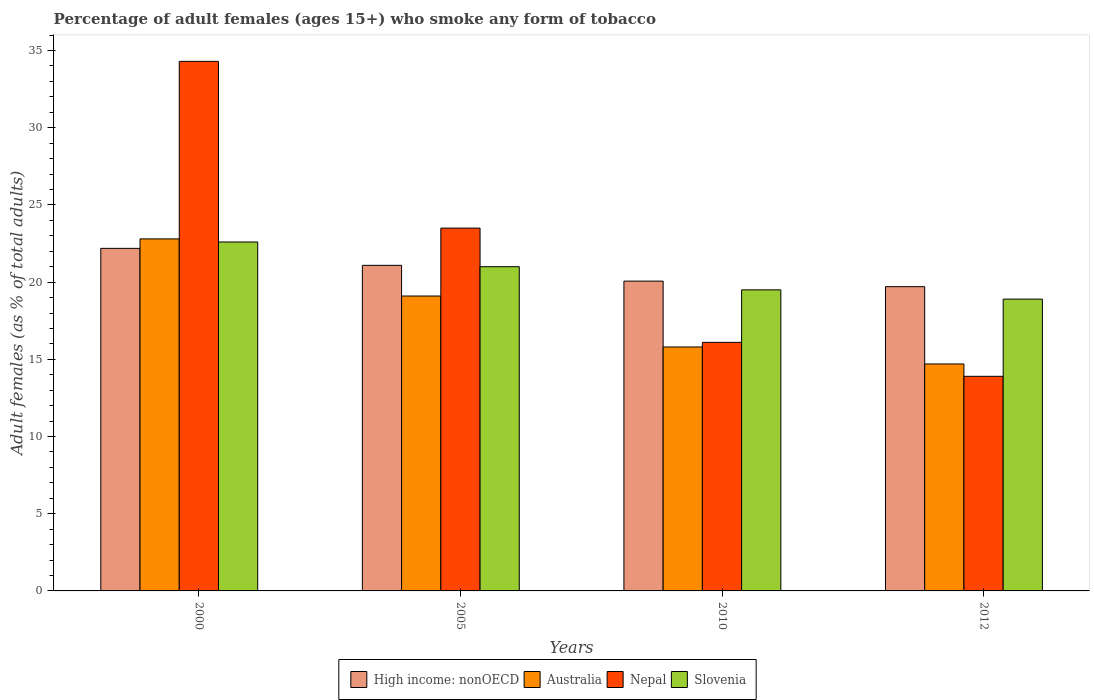How many different coloured bars are there?
Keep it short and to the point. 4. Are the number of bars per tick equal to the number of legend labels?
Offer a very short reply. Yes. Are the number of bars on each tick of the X-axis equal?
Your answer should be compact. Yes. How many bars are there on the 3rd tick from the left?
Your response must be concise. 4. What is the label of the 2nd group of bars from the left?
Ensure brevity in your answer.  2005. What is the percentage of adult females who smoke in High income: nonOECD in 2000?
Your answer should be very brief. 22.19. Across all years, what is the maximum percentage of adult females who smoke in High income: nonOECD?
Provide a succinct answer. 22.19. In which year was the percentage of adult females who smoke in Slovenia maximum?
Your answer should be compact. 2000. In which year was the percentage of adult females who smoke in High income: nonOECD minimum?
Offer a very short reply. 2012. What is the total percentage of adult females who smoke in High income: nonOECD in the graph?
Offer a terse response. 83.05. What is the difference between the percentage of adult females who smoke in Australia in 2000 and the percentage of adult females who smoke in Slovenia in 2012?
Provide a short and direct response. 3.9. In the year 2010, what is the difference between the percentage of adult females who smoke in High income: nonOECD and percentage of adult females who smoke in Nepal?
Offer a very short reply. 3.97. In how many years, is the percentage of adult females who smoke in High income: nonOECD greater than 16 %?
Keep it short and to the point. 4. What is the ratio of the percentage of adult females who smoke in Australia in 2000 to that in 2010?
Give a very brief answer. 1.44. What is the difference between the highest and the second highest percentage of adult females who smoke in Australia?
Offer a very short reply. 3.7. What is the difference between the highest and the lowest percentage of adult females who smoke in Australia?
Provide a short and direct response. 8.1. Is it the case that in every year, the sum of the percentage of adult females who smoke in High income: nonOECD and percentage of adult females who smoke in Australia is greater than the sum of percentage of adult females who smoke in Slovenia and percentage of adult females who smoke in Nepal?
Give a very brief answer. No. What does the 3rd bar from the left in 2010 represents?
Make the answer very short. Nepal. What does the 1st bar from the right in 2005 represents?
Make the answer very short. Slovenia. How many bars are there?
Give a very brief answer. 16. What is the difference between two consecutive major ticks on the Y-axis?
Offer a very short reply. 5. Does the graph contain grids?
Your answer should be very brief. No. How many legend labels are there?
Provide a succinct answer. 4. How are the legend labels stacked?
Ensure brevity in your answer.  Horizontal. What is the title of the graph?
Give a very brief answer. Percentage of adult females (ages 15+) who smoke any form of tobacco. What is the label or title of the X-axis?
Give a very brief answer. Years. What is the label or title of the Y-axis?
Make the answer very short. Adult females (as % of total adults). What is the Adult females (as % of total adults) in High income: nonOECD in 2000?
Your answer should be compact. 22.19. What is the Adult females (as % of total adults) in Australia in 2000?
Offer a very short reply. 22.8. What is the Adult females (as % of total adults) of Nepal in 2000?
Your answer should be compact. 34.3. What is the Adult females (as % of total adults) of Slovenia in 2000?
Your answer should be compact. 22.6. What is the Adult females (as % of total adults) in High income: nonOECD in 2005?
Your response must be concise. 21.09. What is the Adult females (as % of total adults) of Australia in 2005?
Offer a terse response. 19.1. What is the Adult females (as % of total adults) of Slovenia in 2005?
Your answer should be compact. 21. What is the Adult females (as % of total adults) in High income: nonOECD in 2010?
Offer a very short reply. 20.07. What is the Adult females (as % of total adults) of Slovenia in 2010?
Provide a short and direct response. 19.5. What is the Adult females (as % of total adults) of High income: nonOECD in 2012?
Your answer should be very brief. 19.71. What is the Adult females (as % of total adults) of Nepal in 2012?
Your response must be concise. 13.9. What is the Adult females (as % of total adults) in Slovenia in 2012?
Give a very brief answer. 18.9. Across all years, what is the maximum Adult females (as % of total adults) of High income: nonOECD?
Your answer should be very brief. 22.19. Across all years, what is the maximum Adult females (as % of total adults) of Australia?
Your answer should be compact. 22.8. Across all years, what is the maximum Adult females (as % of total adults) in Nepal?
Your answer should be compact. 34.3. Across all years, what is the maximum Adult females (as % of total adults) in Slovenia?
Give a very brief answer. 22.6. Across all years, what is the minimum Adult females (as % of total adults) in High income: nonOECD?
Your response must be concise. 19.71. Across all years, what is the minimum Adult females (as % of total adults) of Australia?
Provide a short and direct response. 14.7. Across all years, what is the minimum Adult females (as % of total adults) of Slovenia?
Keep it short and to the point. 18.9. What is the total Adult females (as % of total adults) in High income: nonOECD in the graph?
Your answer should be compact. 83.05. What is the total Adult females (as % of total adults) in Australia in the graph?
Provide a short and direct response. 72.4. What is the total Adult females (as % of total adults) of Nepal in the graph?
Offer a terse response. 87.8. What is the difference between the Adult females (as % of total adults) of High income: nonOECD in 2000 and that in 2005?
Provide a succinct answer. 1.1. What is the difference between the Adult females (as % of total adults) of Australia in 2000 and that in 2005?
Offer a very short reply. 3.7. What is the difference between the Adult females (as % of total adults) in Slovenia in 2000 and that in 2005?
Your response must be concise. 1.6. What is the difference between the Adult females (as % of total adults) of High income: nonOECD in 2000 and that in 2010?
Your answer should be compact. 2.12. What is the difference between the Adult females (as % of total adults) of Australia in 2000 and that in 2010?
Ensure brevity in your answer.  7. What is the difference between the Adult females (as % of total adults) in Nepal in 2000 and that in 2010?
Make the answer very short. 18.2. What is the difference between the Adult females (as % of total adults) in High income: nonOECD in 2000 and that in 2012?
Provide a succinct answer. 2.48. What is the difference between the Adult females (as % of total adults) of Australia in 2000 and that in 2012?
Keep it short and to the point. 8.1. What is the difference between the Adult females (as % of total adults) of Nepal in 2000 and that in 2012?
Provide a succinct answer. 20.4. What is the difference between the Adult females (as % of total adults) in High income: nonOECD in 2005 and that in 2010?
Make the answer very short. 1.02. What is the difference between the Adult females (as % of total adults) of Slovenia in 2005 and that in 2010?
Keep it short and to the point. 1.5. What is the difference between the Adult females (as % of total adults) of High income: nonOECD in 2005 and that in 2012?
Keep it short and to the point. 1.38. What is the difference between the Adult females (as % of total adults) in Australia in 2005 and that in 2012?
Offer a terse response. 4.4. What is the difference between the Adult females (as % of total adults) in Nepal in 2005 and that in 2012?
Offer a very short reply. 9.6. What is the difference between the Adult females (as % of total adults) of High income: nonOECD in 2010 and that in 2012?
Your answer should be compact. 0.36. What is the difference between the Adult females (as % of total adults) in Australia in 2010 and that in 2012?
Give a very brief answer. 1.1. What is the difference between the Adult females (as % of total adults) in Nepal in 2010 and that in 2012?
Provide a succinct answer. 2.2. What is the difference between the Adult females (as % of total adults) in High income: nonOECD in 2000 and the Adult females (as % of total adults) in Australia in 2005?
Provide a short and direct response. 3.09. What is the difference between the Adult females (as % of total adults) of High income: nonOECD in 2000 and the Adult females (as % of total adults) of Nepal in 2005?
Ensure brevity in your answer.  -1.31. What is the difference between the Adult females (as % of total adults) of High income: nonOECD in 2000 and the Adult females (as % of total adults) of Slovenia in 2005?
Give a very brief answer. 1.19. What is the difference between the Adult females (as % of total adults) in Australia in 2000 and the Adult females (as % of total adults) in Nepal in 2005?
Your response must be concise. -0.7. What is the difference between the Adult females (as % of total adults) of Australia in 2000 and the Adult females (as % of total adults) of Slovenia in 2005?
Your response must be concise. 1.8. What is the difference between the Adult females (as % of total adults) in High income: nonOECD in 2000 and the Adult females (as % of total adults) in Australia in 2010?
Make the answer very short. 6.39. What is the difference between the Adult females (as % of total adults) in High income: nonOECD in 2000 and the Adult females (as % of total adults) in Nepal in 2010?
Provide a succinct answer. 6.09. What is the difference between the Adult females (as % of total adults) of High income: nonOECD in 2000 and the Adult females (as % of total adults) of Slovenia in 2010?
Your answer should be very brief. 2.69. What is the difference between the Adult females (as % of total adults) of Australia in 2000 and the Adult females (as % of total adults) of Nepal in 2010?
Keep it short and to the point. 6.7. What is the difference between the Adult females (as % of total adults) in High income: nonOECD in 2000 and the Adult females (as % of total adults) in Australia in 2012?
Provide a succinct answer. 7.49. What is the difference between the Adult females (as % of total adults) in High income: nonOECD in 2000 and the Adult females (as % of total adults) in Nepal in 2012?
Give a very brief answer. 8.29. What is the difference between the Adult females (as % of total adults) of High income: nonOECD in 2000 and the Adult females (as % of total adults) of Slovenia in 2012?
Your response must be concise. 3.29. What is the difference between the Adult females (as % of total adults) in Australia in 2000 and the Adult females (as % of total adults) in Nepal in 2012?
Provide a succinct answer. 8.9. What is the difference between the Adult females (as % of total adults) in High income: nonOECD in 2005 and the Adult females (as % of total adults) in Australia in 2010?
Provide a succinct answer. 5.29. What is the difference between the Adult females (as % of total adults) of High income: nonOECD in 2005 and the Adult females (as % of total adults) of Nepal in 2010?
Offer a terse response. 4.99. What is the difference between the Adult females (as % of total adults) of High income: nonOECD in 2005 and the Adult females (as % of total adults) of Slovenia in 2010?
Your answer should be compact. 1.59. What is the difference between the Adult females (as % of total adults) in High income: nonOECD in 2005 and the Adult females (as % of total adults) in Australia in 2012?
Your response must be concise. 6.39. What is the difference between the Adult females (as % of total adults) in High income: nonOECD in 2005 and the Adult females (as % of total adults) in Nepal in 2012?
Ensure brevity in your answer.  7.19. What is the difference between the Adult females (as % of total adults) in High income: nonOECD in 2005 and the Adult females (as % of total adults) in Slovenia in 2012?
Make the answer very short. 2.19. What is the difference between the Adult females (as % of total adults) of Australia in 2005 and the Adult females (as % of total adults) of Slovenia in 2012?
Your answer should be very brief. 0.2. What is the difference between the Adult females (as % of total adults) of High income: nonOECD in 2010 and the Adult females (as % of total adults) of Australia in 2012?
Keep it short and to the point. 5.37. What is the difference between the Adult females (as % of total adults) in High income: nonOECD in 2010 and the Adult females (as % of total adults) in Nepal in 2012?
Provide a succinct answer. 6.17. What is the difference between the Adult females (as % of total adults) in High income: nonOECD in 2010 and the Adult females (as % of total adults) in Slovenia in 2012?
Make the answer very short. 1.17. What is the difference between the Adult females (as % of total adults) of Australia in 2010 and the Adult females (as % of total adults) of Slovenia in 2012?
Give a very brief answer. -3.1. What is the average Adult females (as % of total adults) of High income: nonOECD per year?
Your answer should be very brief. 20.76. What is the average Adult females (as % of total adults) of Nepal per year?
Offer a very short reply. 21.95. In the year 2000, what is the difference between the Adult females (as % of total adults) in High income: nonOECD and Adult females (as % of total adults) in Australia?
Offer a terse response. -0.61. In the year 2000, what is the difference between the Adult females (as % of total adults) of High income: nonOECD and Adult females (as % of total adults) of Nepal?
Provide a short and direct response. -12.11. In the year 2000, what is the difference between the Adult females (as % of total adults) of High income: nonOECD and Adult females (as % of total adults) of Slovenia?
Give a very brief answer. -0.41. In the year 2000, what is the difference between the Adult females (as % of total adults) in Australia and Adult females (as % of total adults) in Slovenia?
Make the answer very short. 0.2. In the year 2005, what is the difference between the Adult females (as % of total adults) in High income: nonOECD and Adult females (as % of total adults) in Australia?
Make the answer very short. 1.99. In the year 2005, what is the difference between the Adult females (as % of total adults) in High income: nonOECD and Adult females (as % of total adults) in Nepal?
Offer a terse response. -2.41. In the year 2005, what is the difference between the Adult females (as % of total adults) of High income: nonOECD and Adult females (as % of total adults) of Slovenia?
Give a very brief answer. 0.09. In the year 2005, what is the difference between the Adult females (as % of total adults) of Australia and Adult females (as % of total adults) of Nepal?
Ensure brevity in your answer.  -4.4. In the year 2010, what is the difference between the Adult females (as % of total adults) in High income: nonOECD and Adult females (as % of total adults) in Australia?
Make the answer very short. 4.27. In the year 2010, what is the difference between the Adult females (as % of total adults) in High income: nonOECD and Adult females (as % of total adults) in Nepal?
Keep it short and to the point. 3.97. In the year 2010, what is the difference between the Adult females (as % of total adults) in High income: nonOECD and Adult females (as % of total adults) in Slovenia?
Your answer should be very brief. 0.57. In the year 2012, what is the difference between the Adult females (as % of total adults) of High income: nonOECD and Adult females (as % of total adults) of Australia?
Offer a very short reply. 5.01. In the year 2012, what is the difference between the Adult females (as % of total adults) of High income: nonOECD and Adult females (as % of total adults) of Nepal?
Ensure brevity in your answer.  5.81. In the year 2012, what is the difference between the Adult females (as % of total adults) of High income: nonOECD and Adult females (as % of total adults) of Slovenia?
Provide a short and direct response. 0.81. In the year 2012, what is the difference between the Adult females (as % of total adults) of Nepal and Adult females (as % of total adults) of Slovenia?
Provide a succinct answer. -5. What is the ratio of the Adult females (as % of total adults) in High income: nonOECD in 2000 to that in 2005?
Offer a terse response. 1.05. What is the ratio of the Adult females (as % of total adults) of Australia in 2000 to that in 2005?
Ensure brevity in your answer.  1.19. What is the ratio of the Adult females (as % of total adults) of Nepal in 2000 to that in 2005?
Provide a succinct answer. 1.46. What is the ratio of the Adult females (as % of total adults) in Slovenia in 2000 to that in 2005?
Provide a short and direct response. 1.08. What is the ratio of the Adult females (as % of total adults) in High income: nonOECD in 2000 to that in 2010?
Keep it short and to the point. 1.11. What is the ratio of the Adult females (as % of total adults) of Australia in 2000 to that in 2010?
Your response must be concise. 1.44. What is the ratio of the Adult females (as % of total adults) in Nepal in 2000 to that in 2010?
Give a very brief answer. 2.13. What is the ratio of the Adult females (as % of total adults) in Slovenia in 2000 to that in 2010?
Your answer should be compact. 1.16. What is the ratio of the Adult females (as % of total adults) of High income: nonOECD in 2000 to that in 2012?
Your answer should be compact. 1.13. What is the ratio of the Adult females (as % of total adults) of Australia in 2000 to that in 2012?
Give a very brief answer. 1.55. What is the ratio of the Adult females (as % of total adults) of Nepal in 2000 to that in 2012?
Your answer should be compact. 2.47. What is the ratio of the Adult females (as % of total adults) in Slovenia in 2000 to that in 2012?
Ensure brevity in your answer.  1.2. What is the ratio of the Adult females (as % of total adults) of High income: nonOECD in 2005 to that in 2010?
Keep it short and to the point. 1.05. What is the ratio of the Adult females (as % of total adults) of Australia in 2005 to that in 2010?
Your answer should be compact. 1.21. What is the ratio of the Adult females (as % of total adults) of Nepal in 2005 to that in 2010?
Offer a very short reply. 1.46. What is the ratio of the Adult females (as % of total adults) of High income: nonOECD in 2005 to that in 2012?
Give a very brief answer. 1.07. What is the ratio of the Adult females (as % of total adults) in Australia in 2005 to that in 2012?
Make the answer very short. 1.3. What is the ratio of the Adult females (as % of total adults) of Nepal in 2005 to that in 2012?
Your response must be concise. 1.69. What is the ratio of the Adult females (as % of total adults) in Slovenia in 2005 to that in 2012?
Offer a terse response. 1.11. What is the ratio of the Adult females (as % of total adults) in High income: nonOECD in 2010 to that in 2012?
Offer a very short reply. 1.02. What is the ratio of the Adult females (as % of total adults) of Australia in 2010 to that in 2012?
Your response must be concise. 1.07. What is the ratio of the Adult females (as % of total adults) of Nepal in 2010 to that in 2012?
Make the answer very short. 1.16. What is the ratio of the Adult females (as % of total adults) in Slovenia in 2010 to that in 2012?
Your answer should be very brief. 1.03. What is the difference between the highest and the second highest Adult females (as % of total adults) of High income: nonOECD?
Make the answer very short. 1.1. What is the difference between the highest and the second highest Adult females (as % of total adults) in Nepal?
Your response must be concise. 10.8. What is the difference between the highest and the second highest Adult females (as % of total adults) of Slovenia?
Offer a very short reply. 1.6. What is the difference between the highest and the lowest Adult females (as % of total adults) in High income: nonOECD?
Provide a succinct answer. 2.48. What is the difference between the highest and the lowest Adult females (as % of total adults) in Nepal?
Your response must be concise. 20.4. 